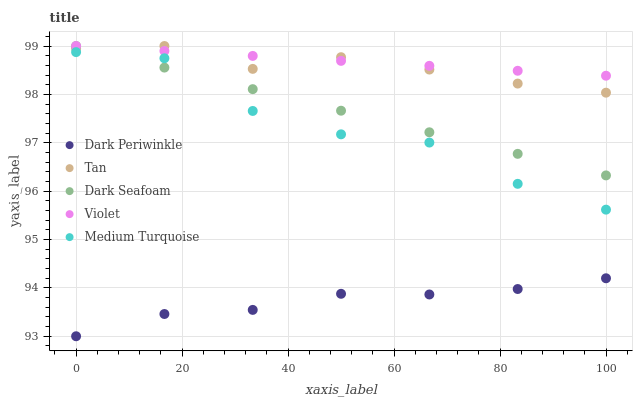Does Dark Periwinkle have the minimum area under the curve?
Answer yes or no. Yes. Does Violet have the maximum area under the curve?
Answer yes or no. Yes. Does Tan have the minimum area under the curve?
Answer yes or no. No. Does Tan have the maximum area under the curve?
Answer yes or no. No. Is Dark Seafoam the smoothest?
Answer yes or no. Yes. Is Medium Turquoise the roughest?
Answer yes or no. Yes. Is Tan the smoothest?
Answer yes or no. No. Is Tan the roughest?
Answer yes or no. No. Does Dark Periwinkle have the lowest value?
Answer yes or no. Yes. Does Tan have the lowest value?
Answer yes or no. No. Does Violet have the highest value?
Answer yes or no. Yes. Does Dark Periwinkle have the highest value?
Answer yes or no. No. Is Dark Periwinkle less than Tan?
Answer yes or no. Yes. Is Medium Turquoise greater than Dark Periwinkle?
Answer yes or no. Yes. Does Dark Seafoam intersect Violet?
Answer yes or no. Yes. Is Dark Seafoam less than Violet?
Answer yes or no. No. Is Dark Seafoam greater than Violet?
Answer yes or no. No. Does Dark Periwinkle intersect Tan?
Answer yes or no. No. 